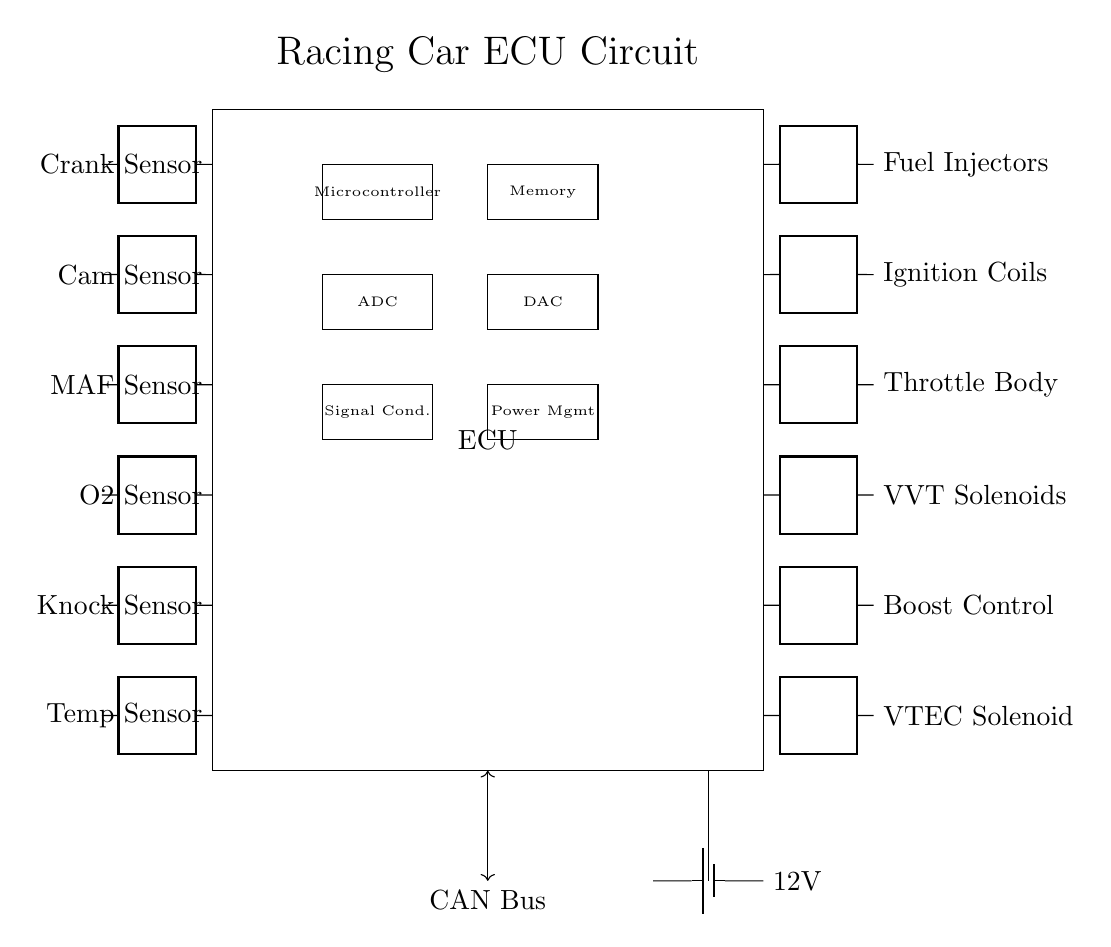What sensors are included in the circuit? The diagram clearly shows six sensor connections labeled as Crank Sensor, Cam Sensor, MAF Sensor, O2 Sensor, Knock Sensor, and Temp Sensor. Each sensor is positioned on the left side of the ECU box, indicating their input roles in engine management.
Answer: Crank Sensor, Cam Sensor, MAF Sensor, O2 Sensor, Knock Sensor, Temp Sensor How many actuators are present in the ECU? The circuit diagram reveals six actuator connections labeled as Fuel Injectors, Ignition Coils, Throttle Body, VVT Solenoids, Boost Control, and VTEC Solenoid. These are positioned on the right side of the ECU box, indicating their output roles.
Answer: Six What role does the microcontroller play in the circuit? The microcontroller is a crucial component shown inside the ECU box. It processes signals from various sensors and sends commands to actuators for efficient engine management. This central processing role is essential for the ECU's overall function.
Answer: Central processing Which bus communication standard does this ECU use? The circuit specifies the use of a CAN Bus for communication, indicated by a bi-directional arrow leading to a labeled section at the bottom of the ECU. CAN Bus is commonly used in automotive systems for robust communication between various electronic components.
Answer: CAN Bus What is the voltage level provided to the ECU? The circuit indicates a 12V supply from a battery, shown on the bottom-right part of the diagram. The labeling clearly states the voltage, which is a standard level for automotive electrical systems, ensuring adequate power for all components.
Answer: 12V What internal component handles analog signals in the ECU? The circuit diagram defines an ADC (Analog to Digital Converter), located within the ECU. This component converts analog signals from sensors into digital signals for processing by the microcontroller, making it vital for correct signal interpretation.
Answer: ADC 